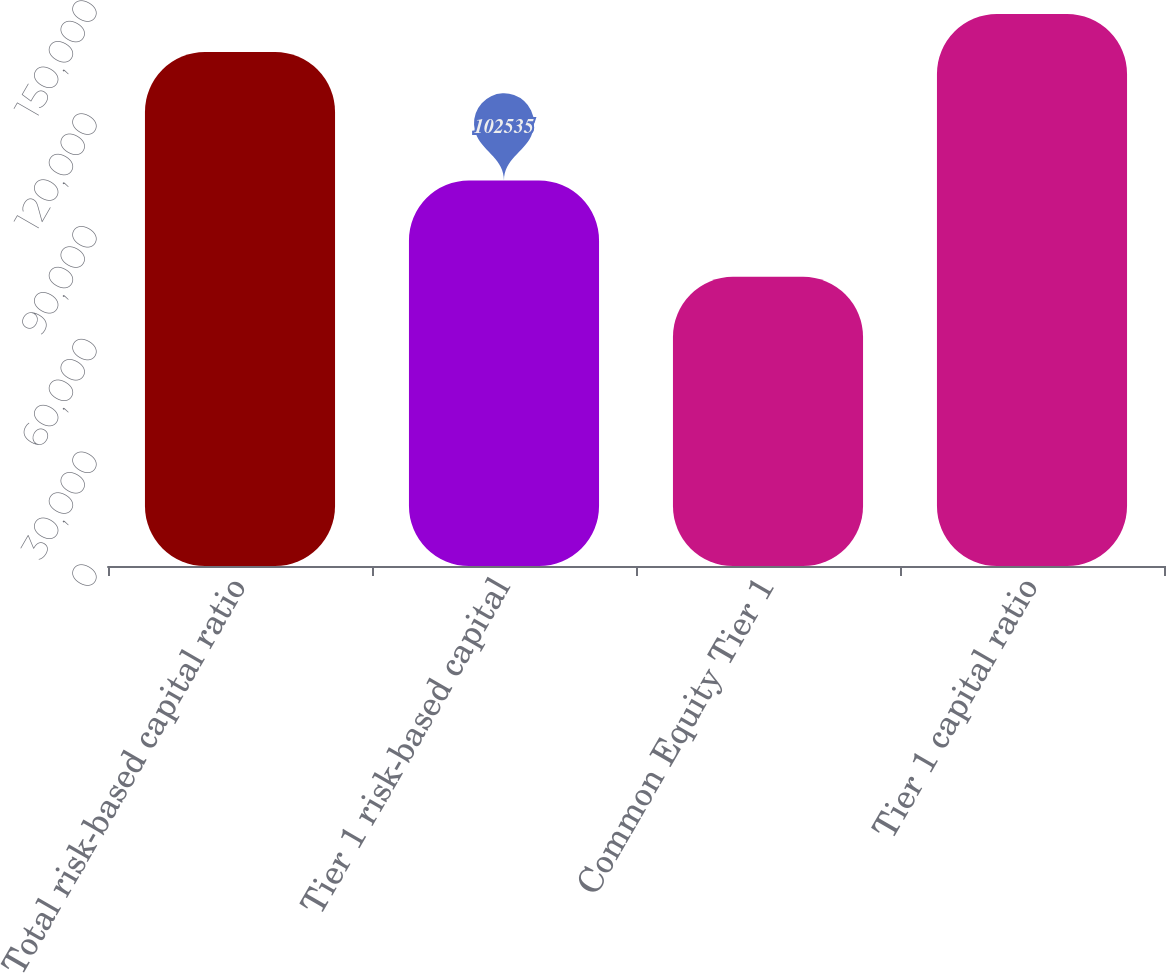Convert chart to OTSL. <chart><loc_0><loc_0><loc_500><loc_500><bar_chart><fcel>Total risk-based capital ratio<fcel>Tier 1 risk-based capital<fcel>Common Equity Tier 1<fcel>Tier 1 capital ratio<nl><fcel>136713<fcel>102535<fcel>76901<fcel>146839<nl></chart> 